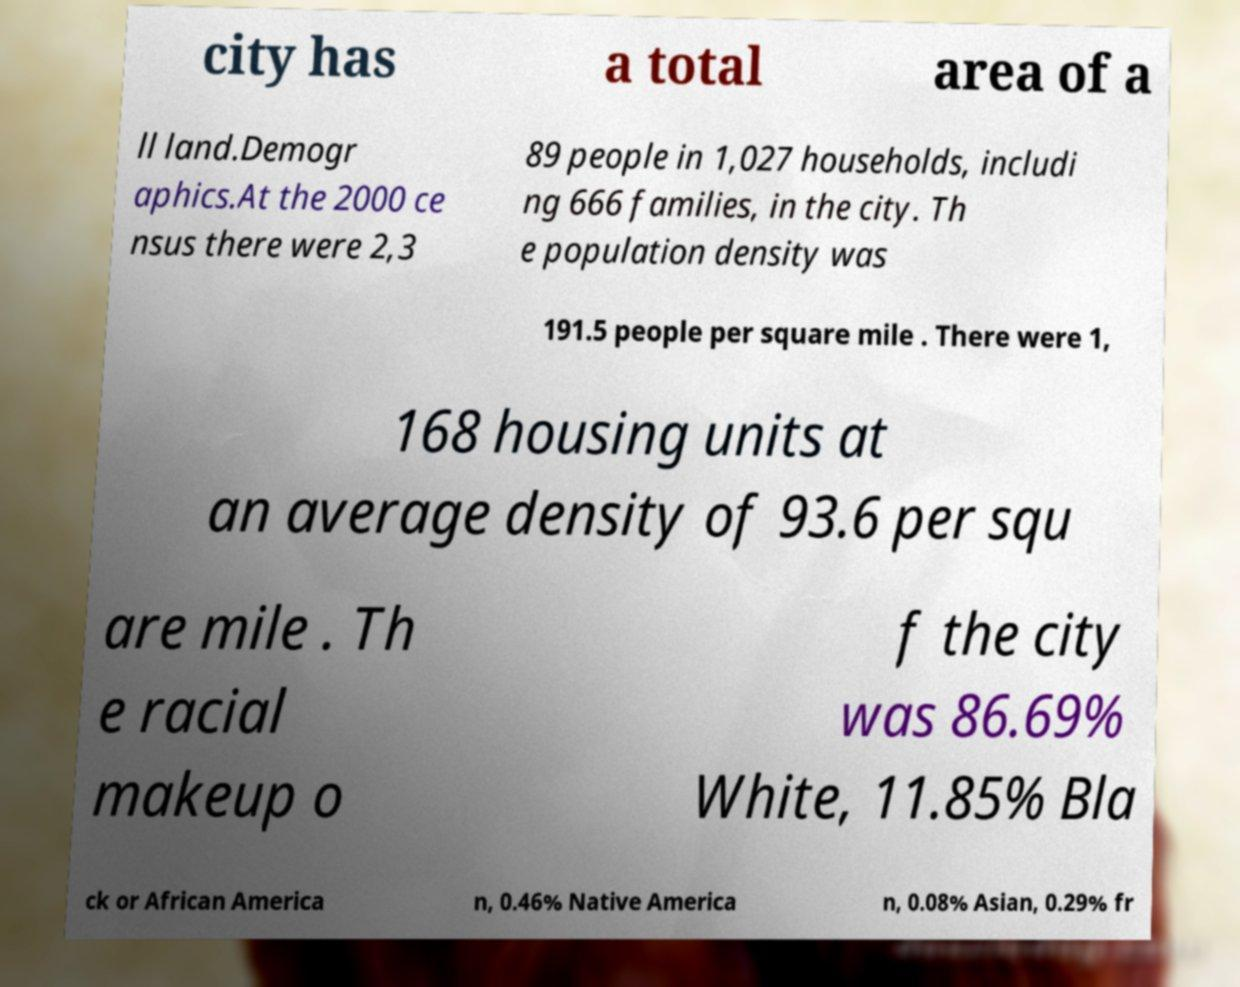Could you extract and type out the text from this image? city has a total area of a ll land.Demogr aphics.At the 2000 ce nsus there were 2,3 89 people in 1,027 households, includi ng 666 families, in the city. Th e population density was 191.5 people per square mile . There were 1, 168 housing units at an average density of 93.6 per squ are mile . Th e racial makeup o f the city was 86.69% White, 11.85% Bla ck or African America n, 0.46% Native America n, 0.08% Asian, 0.29% fr 